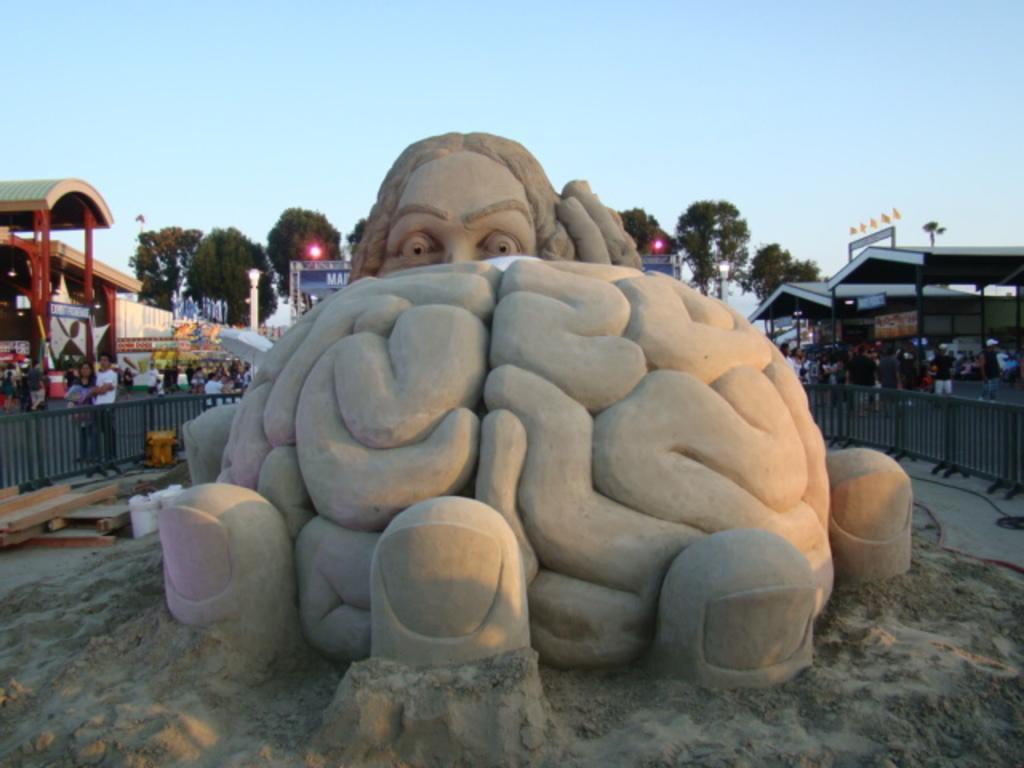Describe this image in one or two sentences. Here we can see sand carving. There is a fence. Here we can see group of people, boards, sheds, lights, poles, and trees. In the background there is sky. 